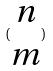<formula> <loc_0><loc_0><loc_500><loc_500>( \begin{matrix} n \\ m \end{matrix} )</formula> 